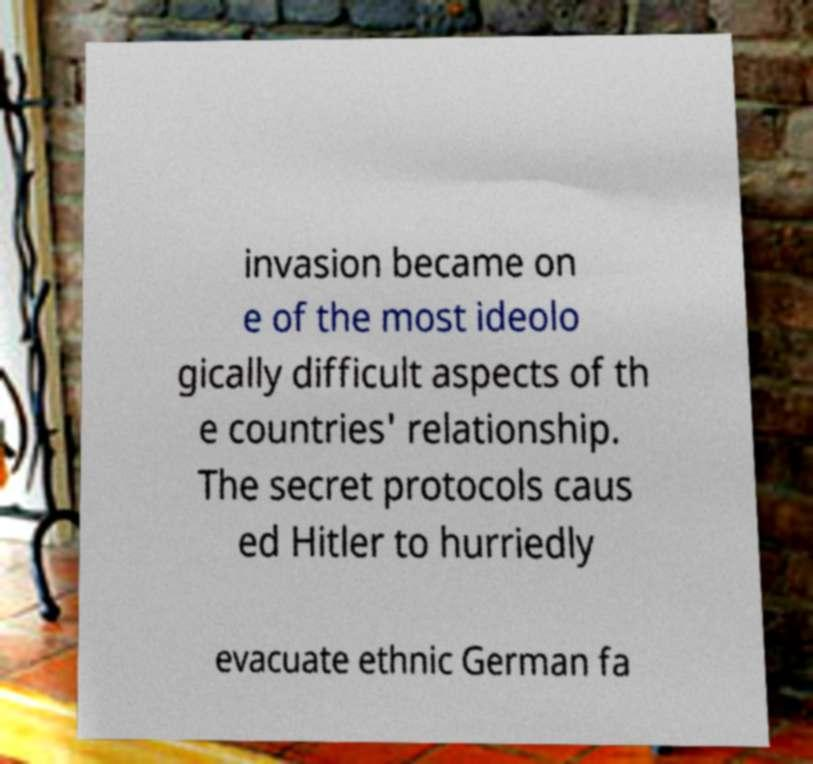Could you assist in decoding the text presented in this image and type it out clearly? invasion became on e of the most ideolo gically difficult aspects of th e countries' relationship. The secret protocols caus ed Hitler to hurriedly evacuate ethnic German fa 